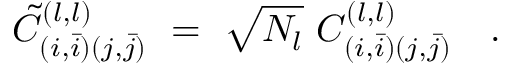Convert formula to latex. <formula><loc_0><loc_0><loc_500><loc_500>{ { \tilde { C } } _ { ( i , \bar { i } ) ( j , \bar { j } ) } } ^ { ( l , l ) } \ = \ { \sqrt { N _ { l } } \ C _ { ( i , \bar { i } ) ( j , \bar { j } ) } ^ { ( l , l ) } } \quad .</formula> 